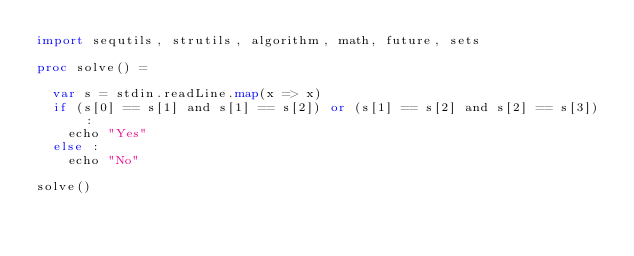<code> <loc_0><loc_0><loc_500><loc_500><_Nim_>import sequtils, strutils, algorithm, math, future, sets

proc solve() =

  var s = stdin.readLine.map(x => x)
  if (s[0] == s[1] and s[1] == s[2]) or (s[1] == s[2] and s[2] == s[3]) : 
    echo "Yes"
  else : 
    echo "No"

solve()
</code> 